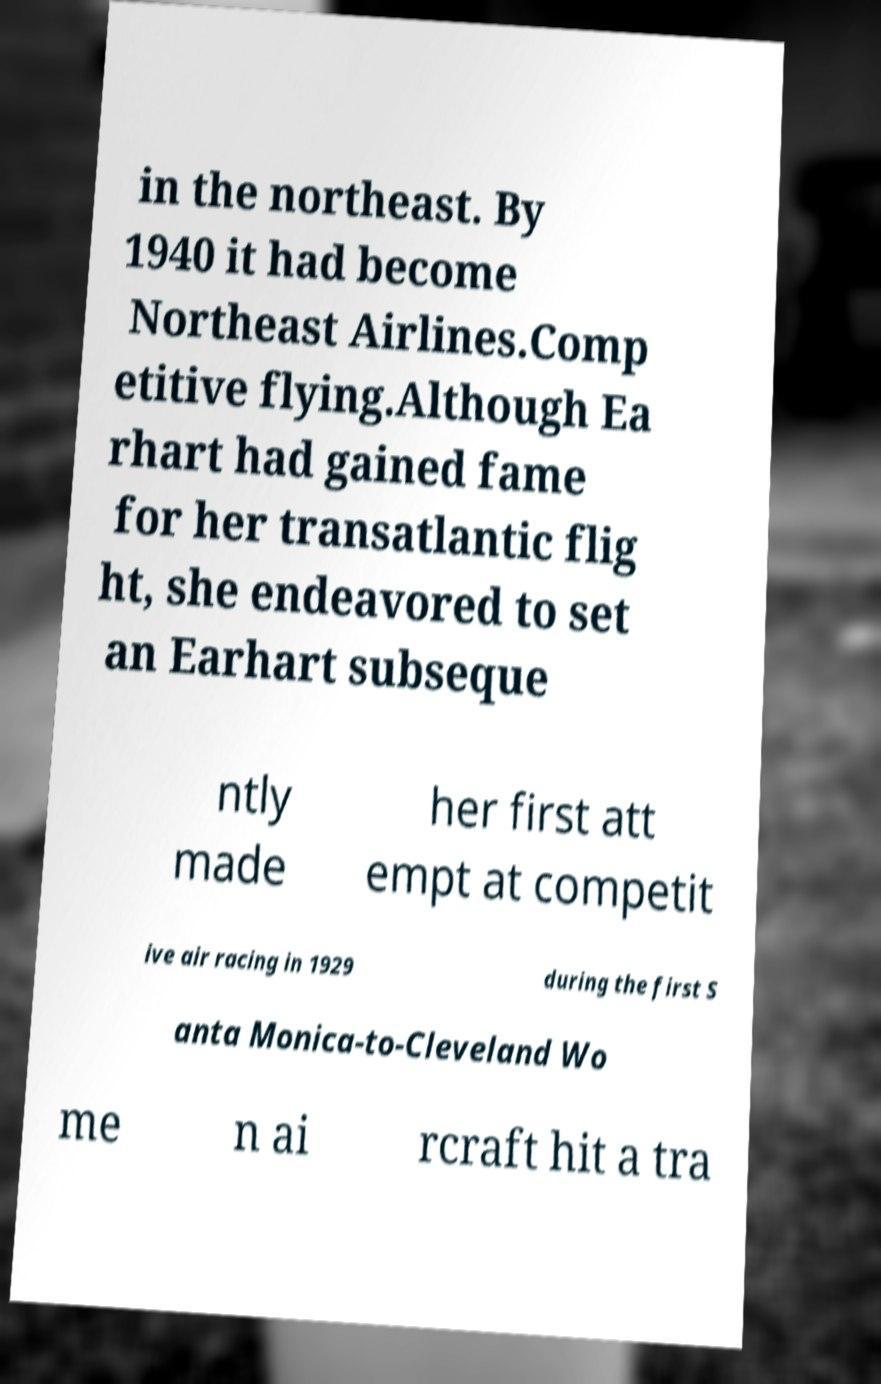Can you accurately transcribe the text from the provided image for me? in the northeast. By 1940 it had become Northeast Airlines.Comp etitive flying.Although Ea rhart had gained fame for her transatlantic flig ht, she endeavored to set an Earhart subseque ntly made her first att empt at competit ive air racing in 1929 during the first S anta Monica-to-Cleveland Wo me n ai rcraft hit a tra 